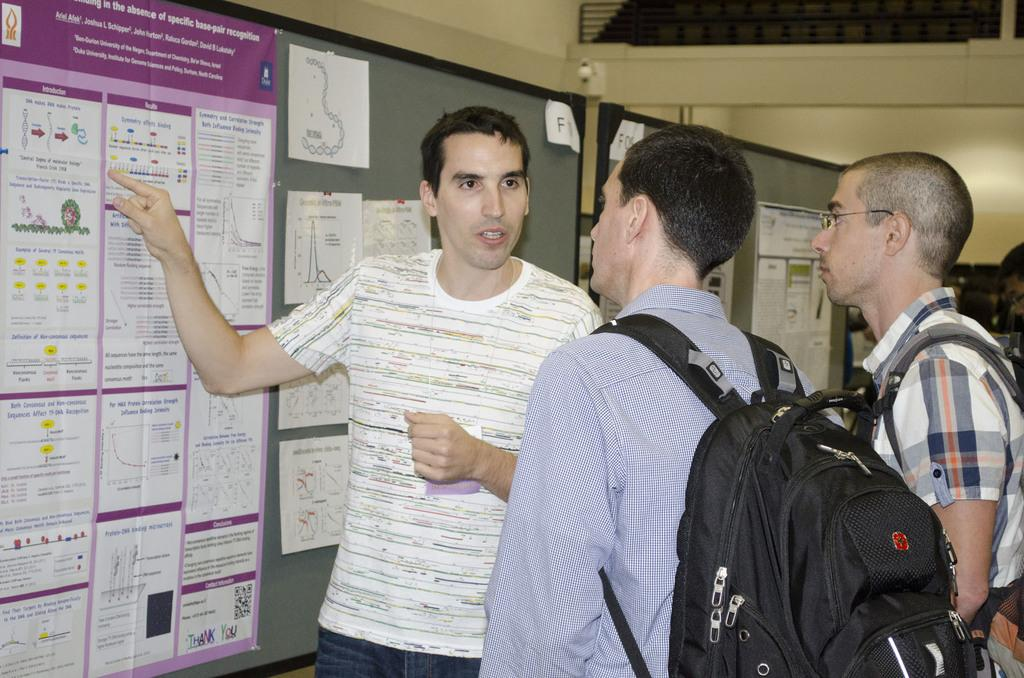<image>
Give a short and clear explanation of the subsequent image. A man points to a poster that has information about base-pair recognition. 